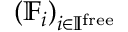Convert formula to latex. <formula><loc_0><loc_0><loc_500><loc_500>\left ( \mathbb { F } _ { i } \right ) _ { i \in \mathbb { I } ^ { f r e e } }</formula> 